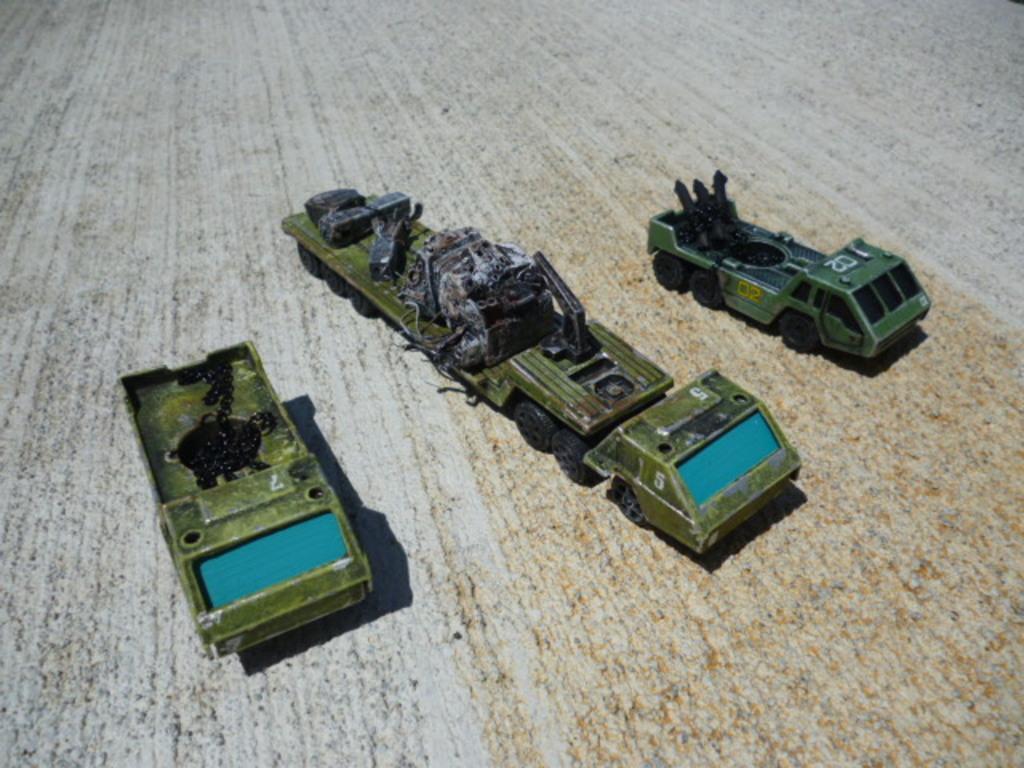In one or two sentences, can you explain what this image depicts? In this image we can see toy vehicles and there are objects on the vehicles on a platform. 